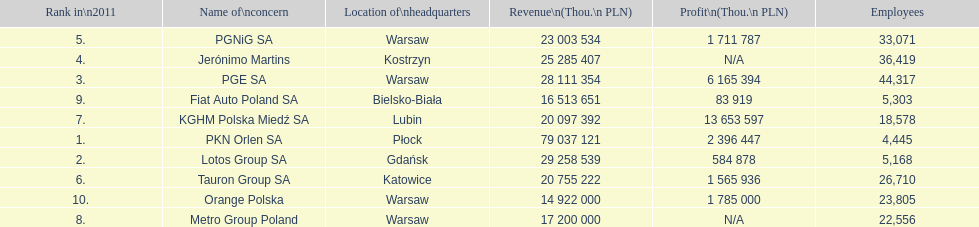Which company had the most revenue? PKN Orlen SA. Could you parse the entire table as a dict? {'header': ['Rank in\\n2011', 'Name of\\nconcern', 'Location of\\nheadquarters', 'Revenue\\n(Thou.\\n\xa0PLN)', 'Profit\\n(Thou.\\n\xa0PLN)', 'Employees'], 'rows': [['5.', 'PGNiG SA', 'Warsaw', '23 003 534', '1 711 787', '33,071'], ['4.', 'Jerónimo Martins', 'Kostrzyn', '25 285 407', 'N/A', '36,419'], ['3.', 'PGE SA', 'Warsaw', '28 111 354', '6 165 394', '44,317'], ['9.', 'Fiat Auto Poland SA', 'Bielsko-Biała', '16 513 651', '83 919', '5,303'], ['7.', 'KGHM Polska Miedź SA', 'Lubin', '20 097 392', '13 653 597', '18,578'], ['1.', 'PKN Orlen SA', 'Płock', '79 037 121', '2 396 447', '4,445'], ['2.', 'Lotos Group SA', 'Gdańsk', '29 258 539', '584 878', '5,168'], ['6.', 'Tauron Group SA', 'Katowice', '20 755 222', '1 565 936', '26,710'], ['10.', 'Orange Polska', 'Warsaw', '14 922 000', '1 785 000', '23,805'], ['8.', 'Metro Group Poland', 'Warsaw', '17 200 000', 'N/A', '22,556']]} 